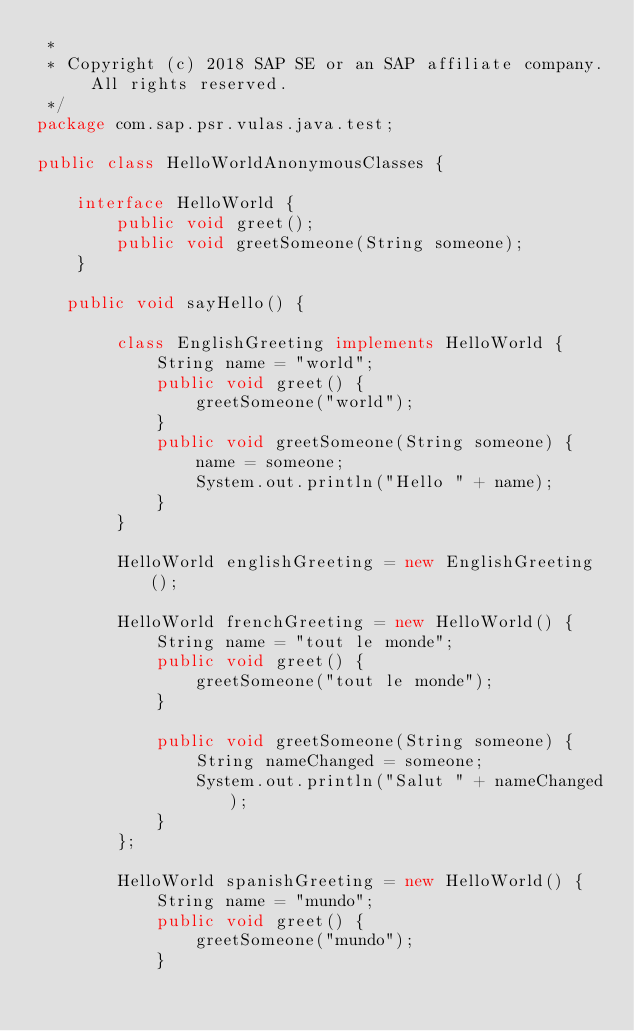<code> <loc_0><loc_0><loc_500><loc_500><_Java_> *
 * Copyright (c) 2018 SAP SE or an SAP affiliate company. All rights reserved.
 */
package com.sap.psr.vulas.java.test;

public class HelloWorldAnonymousClasses {
  
    interface HelloWorld {
        public void greet();
        public void greetSomeone(String someone);
    }
  
   public void sayHello() {
        
        class EnglishGreeting implements HelloWorld {
            String name = "world";
            public void greet() {
                greetSomeone("world");
            }
            public void greetSomeone(String someone) {
                name = someone;
                System.out.println("Hello " + name);
            }
        }
      
        HelloWorld englishGreeting = new EnglishGreeting();
        
        HelloWorld frenchGreeting = new HelloWorld() {
            String name = "tout le monde";
            public void greet() {
                greetSomeone("tout le monde");
            }
            
            public void greetSomeone(String someone) {
                String nameChanged = someone;
                System.out.println("Salut " + nameChanged);
            }
        };
        
        HelloWorld spanishGreeting = new HelloWorld() {
            String name = "mundo";
            public void greet() {
                greetSomeone("mundo");
            }</code> 